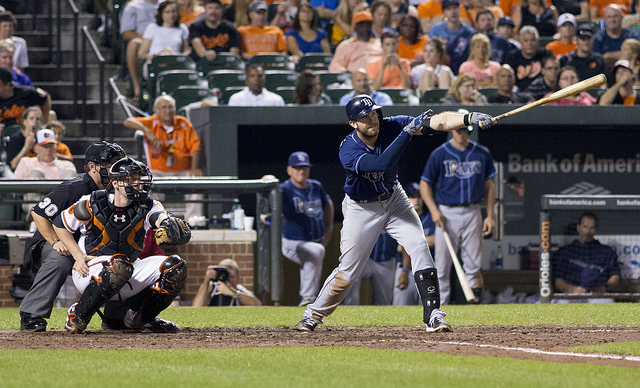Identify and read out the text in this image. Banh Of TB 30 Amer 